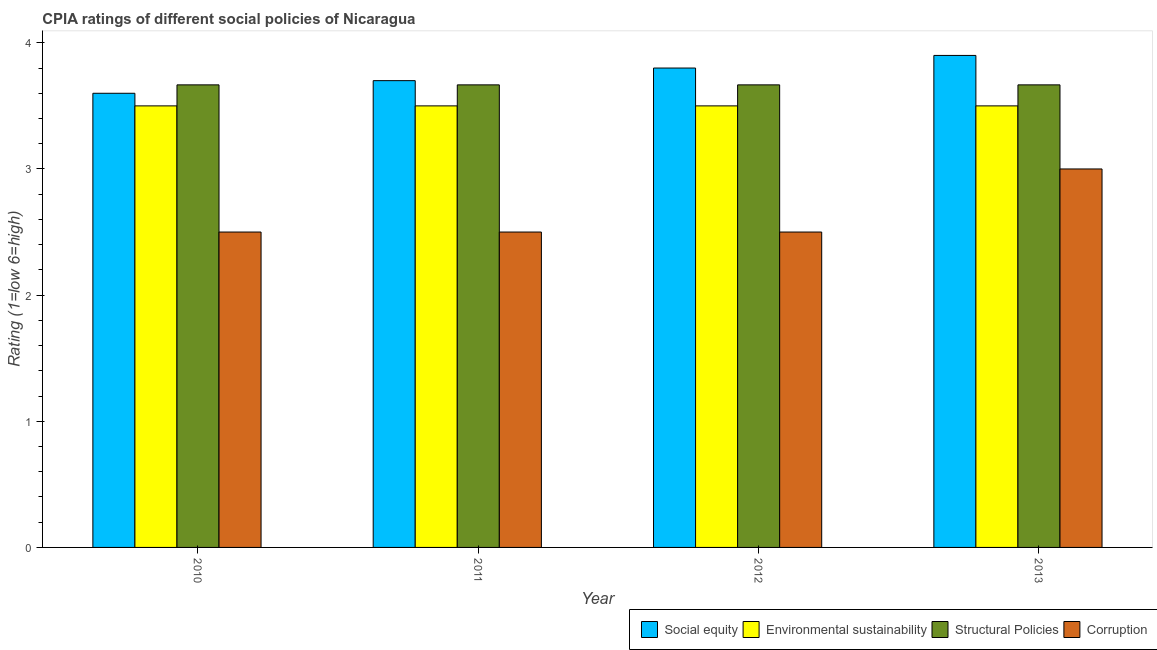How many different coloured bars are there?
Your answer should be compact. 4. How many groups of bars are there?
Provide a succinct answer. 4. Are the number of bars on each tick of the X-axis equal?
Give a very brief answer. Yes. How many bars are there on the 3rd tick from the left?
Make the answer very short. 4. Across all years, what is the minimum cpia rating of corruption?
Keep it short and to the point. 2.5. In which year was the cpia rating of corruption maximum?
Keep it short and to the point. 2013. What is the total cpia rating of structural policies in the graph?
Offer a terse response. 14.67. What is the difference between the cpia rating of corruption in 2011 and that in 2013?
Offer a very short reply. -0.5. What is the difference between the cpia rating of social equity in 2012 and the cpia rating of corruption in 2011?
Offer a very short reply. 0.1. What is the average cpia rating of environmental sustainability per year?
Your answer should be compact. 3.5. In how many years, is the cpia rating of corruption greater than 3.8?
Your answer should be compact. 0. What is the ratio of the cpia rating of environmental sustainability in 2010 to that in 2012?
Your answer should be compact. 1. Is the difference between the cpia rating of structural policies in 2011 and 2013 greater than the difference between the cpia rating of social equity in 2011 and 2013?
Give a very brief answer. No. What is the difference between the highest and the second highest cpia rating of structural policies?
Keep it short and to the point. 0. What is the difference between the highest and the lowest cpia rating of social equity?
Give a very brief answer. 0.3. Is the sum of the cpia rating of corruption in 2010 and 2012 greater than the maximum cpia rating of structural policies across all years?
Ensure brevity in your answer.  Yes. Is it the case that in every year, the sum of the cpia rating of structural policies and cpia rating of corruption is greater than the sum of cpia rating of social equity and cpia rating of environmental sustainability?
Your answer should be very brief. No. What does the 3rd bar from the left in 2012 represents?
Give a very brief answer. Structural Policies. What does the 4th bar from the right in 2011 represents?
Your answer should be compact. Social equity. Is it the case that in every year, the sum of the cpia rating of social equity and cpia rating of environmental sustainability is greater than the cpia rating of structural policies?
Your response must be concise. Yes. Are all the bars in the graph horizontal?
Keep it short and to the point. No. What is the difference between two consecutive major ticks on the Y-axis?
Give a very brief answer. 1. Does the graph contain any zero values?
Give a very brief answer. No. Where does the legend appear in the graph?
Offer a very short reply. Bottom right. How are the legend labels stacked?
Provide a short and direct response. Horizontal. What is the title of the graph?
Give a very brief answer. CPIA ratings of different social policies of Nicaragua. What is the Rating (1=low 6=high) of Social equity in 2010?
Offer a terse response. 3.6. What is the Rating (1=low 6=high) in Structural Policies in 2010?
Your response must be concise. 3.67. What is the Rating (1=low 6=high) in Structural Policies in 2011?
Provide a short and direct response. 3.67. What is the Rating (1=low 6=high) in Structural Policies in 2012?
Provide a short and direct response. 3.67. What is the Rating (1=low 6=high) in Social equity in 2013?
Your answer should be very brief. 3.9. What is the Rating (1=low 6=high) in Structural Policies in 2013?
Offer a terse response. 3.67. What is the Rating (1=low 6=high) of Corruption in 2013?
Provide a short and direct response. 3. Across all years, what is the maximum Rating (1=low 6=high) in Social equity?
Provide a short and direct response. 3.9. Across all years, what is the maximum Rating (1=low 6=high) in Structural Policies?
Keep it short and to the point. 3.67. Across all years, what is the minimum Rating (1=low 6=high) in Environmental sustainability?
Ensure brevity in your answer.  3.5. Across all years, what is the minimum Rating (1=low 6=high) of Structural Policies?
Keep it short and to the point. 3.67. What is the total Rating (1=low 6=high) of Environmental sustainability in the graph?
Ensure brevity in your answer.  14. What is the total Rating (1=low 6=high) in Structural Policies in the graph?
Keep it short and to the point. 14.67. What is the difference between the Rating (1=low 6=high) of Environmental sustainability in 2010 and that in 2011?
Provide a short and direct response. 0. What is the difference between the Rating (1=low 6=high) in Structural Policies in 2010 and that in 2011?
Your response must be concise. 0. What is the difference between the Rating (1=low 6=high) of Environmental sustainability in 2010 and that in 2012?
Provide a short and direct response. 0. What is the difference between the Rating (1=low 6=high) of Structural Policies in 2010 and that in 2012?
Give a very brief answer. 0. What is the difference between the Rating (1=low 6=high) of Environmental sustainability in 2010 and that in 2013?
Your answer should be very brief. 0. What is the difference between the Rating (1=low 6=high) in Structural Policies in 2010 and that in 2013?
Ensure brevity in your answer.  0. What is the difference between the Rating (1=low 6=high) of Corruption in 2010 and that in 2013?
Offer a very short reply. -0.5. What is the difference between the Rating (1=low 6=high) in Social equity in 2011 and that in 2012?
Your response must be concise. -0.1. What is the difference between the Rating (1=low 6=high) in Environmental sustainability in 2011 and that in 2012?
Provide a succinct answer. 0. What is the difference between the Rating (1=low 6=high) in Corruption in 2011 and that in 2012?
Your answer should be compact. 0. What is the difference between the Rating (1=low 6=high) of Environmental sustainability in 2011 and that in 2013?
Offer a very short reply. 0. What is the difference between the Rating (1=low 6=high) in Environmental sustainability in 2012 and that in 2013?
Provide a succinct answer. 0. What is the difference between the Rating (1=low 6=high) of Structural Policies in 2012 and that in 2013?
Offer a terse response. 0. What is the difference between the Rating (1=low 6=high) of Social equity in 2010 and the Rating (1=low 6=high) of Structural Policies in 2011?
Your answer should be compact. -0.07. What is the difference between the Rating (1=low 6=high) in Social equity in 2010 and the Rating (1=low 6=high) in Corruption in 2011?
Provide a succinct answer. 1.1. What is the difference between the Rating (1=low 6=high) in Environmental sustainability in 2010 and the Rating (1=low 6=high) in Structural Policies in 2011?
Provide a succinct answer. -0.17. What is the difference between the Rating (1=low 6=high) of Social equity in 2010 and the Rating (1=low 6=high) of Structural Policies in 2012?
Give a very brief answer. -0.07. What is the difference between the Rating (1=low 6=high) in Structural Policies in 2010 and the Rating (1=low 6=high) in Corruption in 2012?
Make the answer very short. 1.17. What is the difference between the Rating (1=low 6=high) of Social equity in 2010 and the Rating (1=low 6=high) of Structural Policies in 2013?
Make the answer very short. -0.07. What is the difference between the Rating (1=low 6=high) in Social equity in 2010 and the Rating (1=low 6=high) in Corruption in 2013?
Your response must be concise. 0.6. What is the difference between the Rating (1=low 6=high) in Environmental sustainability in 2010 and the Rating (1=low 6=high) in Corruption in 2013?
Keep it short and to the point. 0.5. What is the difference between the Rating (1=low 6=high) in Structural Policies in 2010 and the Rating (1=low 6=high) in Corruption in 2013?
Offer a terse response. 0.67. What is the difference between the Rating (1=low 6=high) of Social equity in 2011 and the Rating (1=low 6=high) of Environmental sustainability in 2012?
Your response must be concise. 0.2. What is the difference between the Rating (1=low 6=high) in Social equity in 2011 and the Rating (1=low 6=high) in Corruption in 2012?
Give a very brief answer. 1.2. What is the difference between the Rating (1=low 6=high) in Environmental sustainability in 2011 and the Rating (1=low 6=high) in Corruption in 2012?
Your answer should be very brief. 1. What is the difference between the Rating (1=low 6=high) in Social equity in 2011 and the Rating (1=low 6=high) in Structural Policies in 2013?
Your answer should be compact. 0.03. What is the difference between the Rating (1=low 6=high) in Environmental sustainability in 2011 and the Rating (1=low 6=high) in Structural Policies in 2013?
Offer a terse response. -0.17. What is the difference between the Rating (1=low 6=high) of Environmental sustainability in 2011 and the Rating (1=low 6=high) of Corruption in 2013?
Offer a terse response. 0.5. What is the difference between the Rating (1=low 6=high) in Structural Policies in 2011 and the Rating (1=low 6=high) in Corruption in 2013?
Your answer should be compact. 0.67. What is the difference between the Rating (1=low 6=high) of Social equity in 2012 and the Rating (1=low 6=high) of Structural Policies in 2013?
Offer a terse response. 0.13. What is the difference between the Rating (1=low 6=high) of Social equity in 2012 and the Rating (1=low 6=high) of Corruption in 2013?
Keep it short and to the point. 0.8. What is the difference between the Rating (1=low 6=high) of Environmental sustainability in 2012 and the Rating (1=low 6=high) of Corruption in 2013?
Offer a very short reply. 0.5. What is the difference between the Rating (1=low 6=high) of Structural Policies in 2012 and the Rating (1=low 6=high) of Corruption in 2013?
Your response must be concise. 0.67. What is the average Rating (1=low 6=high) in Social equity per year?
Keep it short and to the point. 3.75. What is the average Rating (1=low 6=high) of Environmental sustainability per year?
Ensure brevity in your answer.  3.5. What is the average Rating (1=low 6=high) of Structural Policies per year?
Offer a very short reply. 3.67. What is the average Rating (1=low 6=high) in Corruption per year?
Give a very brief answer. 2.62. In the year 2010, what is the difference between the Rating (1=low 6=high) of Social equity and Rating (1=low 6=high) of Environmental sustainability?
Provide a succinct answer. 0.1. In the year 2010, what is the difference between the Rating (1=low 6=high) of Social equity and Rating (1=low 6=high) of Structural Policies?
Provide a succinct answer. -0.07. In the year 2010, what is the difference between the Rating (1=low 6=high) of Social equity and Rating (1=low 6=high) of Corruption?
Make the answer very short. 1.1. In the year 2010, what is the difference between the Rating (1=low 6=high) in Environmental sustainability and Rating (1=low 6=high) in Corruption?
Keep it short and to the point. 1. In the year 2010, what is the difference between the Rating (1=low 6=high) in Structural Policies and Rating (1=low 6=high) in Corruption?
Ensure brevity in your answer.  1.17. In the year 2011, what is the difference between the Rating (1=low 6=high) of Social equity and Rating (1=low 6=high) of Environmental sustainability?
Keep it short and to the point. 0.2. In the year 2011, what is the difference between the Rating (1=low 6=high) in Social equity and Rating (1=low 6=high) in Structural Policies?
Your response must be concise. 0.03. In the year 2011, what is the difference between the Rating (1=low 6=high) in Social equity and Rating (1=low 6=high) in Corruption?
Ensure brevity in your answer.  1.2. In the year 2011, what is the difference between the Rating (1=low 6=high) in Environmental sustainability and Rating (1=low 6=high) in Structural Policies?
Provide a short and direct response. -0.17. In the year 2012, what is the difference between the Rating (1=low 6=high) of Social equity and Rating (1=low 6=high) of Environmental sustainability?
Provide a succinct answer. 0.3. In the year 2012, what is the difference between the Rating (1=low 6=high) in Social equity and Rating (1=low 6=high) in Structural Policies?
Give a very brief answer. 0.13. In the year 2012, what is the difference between the Rating (1=low 6=high) in Environmental sustainability and Rating (1=low 6=high) in Structural Policies?
Keep it short and to the point. -0.17. In the year 2012, what is the difference between the Rating (1=low 6=high) of Structural Policies and Rating (1=low 6=high) of Corruption?
Your answer should be very brief. 1.17. In the year 2013, what is the difference between the Rating (1=low 6=high) in Social equity and Rating (1=low 6=high) in Structural Policies?
Your response must be concise. 0.23. In the year 2013, what is the difference between the Rating (1=low 6=high) in Social equity and Rating (1=low 6=high) in Corruption?
Give a very brief answer. 0.9. In the year 2013, what is the difference between the Rating (1=low 6=high) of Environmental sustainability and Rating (1=low 6=high) of Structural Policies?
Your answer should be very brief. -0.17. In the year 2013, what is the difference between the Rating (1=low 6=high) in Environmental sustainability and Rating (1=low 6=high) in Corruption?
Your response must be concise. 0.5. What is the ratio of the Rating (1=low 6=high) of Environmental sustainability in 2010 to that in 2011?
Ensure brevity in your answer.  1. What is the ratio of the Rating (1=low 6=high) in Structural Policies in 2010 to that in 2011?
Ensure brevity in your answer.  1. What is the ratio of the Rating (1=low 6=high) of Social equity in 2010 to that in 2012?
Provide a succinct answer. 0.95. What is the ratio of the Rating (1=low 6=high) of Structural Policies in 2010 to that in 2012?
Provide a short and direct response. 1. What is the ratio of the Rating (1=low 6=high) in Corruption in 2010 to that in 2012?
Keep it short and to the point. 1. What is the ratio of the Rating (1=low 6=high) in Structural Policies in 2010 to that in 2013?
Keep it short and to the point. 1. What is the ratio of the Rating (1=low 6=high) of Corruption in 2010 to that in 2013?
Make the answer very short. 0.83. What is the ratio of the Rating (1=low 6=high) in Social equity in 2011 to that in 2012?
Offer a terse response. 0.97. What is the ratio of the Rating (1=low 6=high) of Environmental sustainability in 2011 to that in 2012?
Provide a succinct answer. 1. What is the ratio of the Rating (1=low 6=high) of Structural Policies in 2011 to that in 2012?
Make the answer very short. 1. What is the ratio of the Rating (1=low 6=high) of Corruption in 2011 to that in 2012?
Your answer should be very brief. 1. What is the ratio of the Rating (1=low 6=high) in Social equity in 2011 to that in 2013?
Offer a very short reply. 0.95. What is the ratio of the Rating (1=low 6=high) of Environmental sustainability in 2011 to that in 2013?
Ensure brevity in your answer.  1. What is the ratio of the Rating (1=low 6=high) in Structural Policies in 2011 to that in 2013?
Your answer should be very brief. 1. What is the ratio of the Rating (1=low 6=high) in Corruption in 2011 to that in 2013?
Your answer should be compact. 0.83. What is the ratio of the Rating (1=low 6=high) of Social equity in 2012 to that in 2013?
Make the answer very short. 0.97. What is the ratio of the Rating (1=low 6=high) of Environmental sustainability in 2012 to that in 2013?
Provide a short and direct response. 1. What is the difference between the highest and the second highest Rating (1=low 6=high) in Social equity?
Provide a short and direct response. 0.1. What is the difference between the highest and the second highest Rating (1=low 6=high) in Corruption?
Make the answer very short. 0.5. What is the difference between the highest and the lowest Rating (1=low 6=high) of Environmental sustainability?
Give a very brief answer. 0. What is the difference between the highest and the lowest Rating (1=low 6=high) in Structural Policies?
Offer a terse response. 0. What is the difference between the highest and the lowest Rating (1=low 6=high) in Corruption?
Offer a terse response. 0.5. 